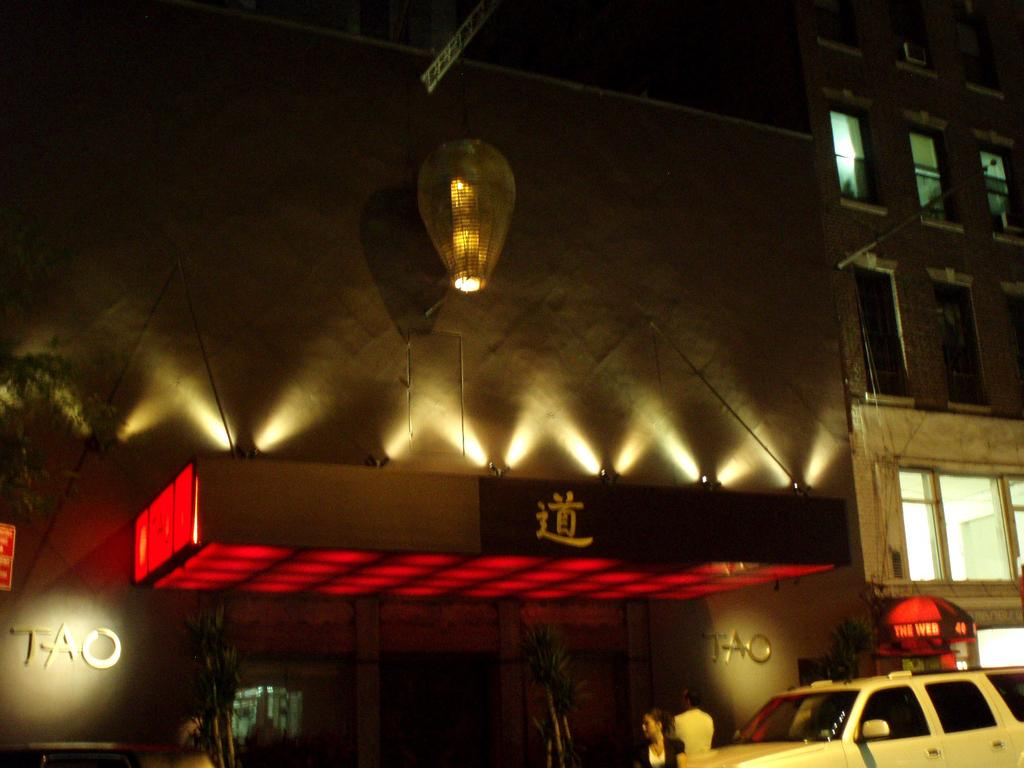<image>
Provide a brief description of the given image. The front of a building that has the word TAO on the wall. 